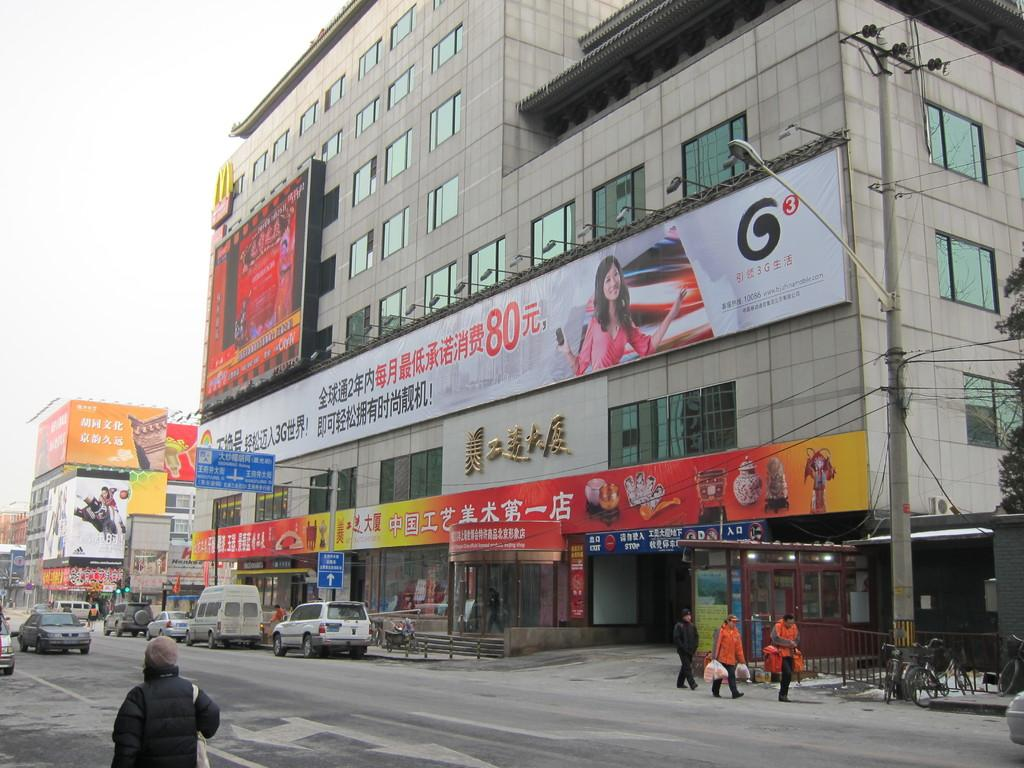What types of structures are visible in the image? There are buildings in the image. What else can be seen in the image besides buildings? There are vehicles and persons visible in the image. Where are the buildings, vehicles, and persons located in the image? They are located in the right corner of the image. Are there any other people in the image? Yes, there is another person in the left corner of the image. What else can be seen in the left corner of the image? There are additional vehicles in the left corner of the image. What invention is being demonstrated by the person in the left corner of the image? There is no invention being demonstrated by the person in the left corner of the image. What impulse is driving the actions of the persons in the image? The provided facts do not give any information about the motivations or impulses of the persons in the image. 